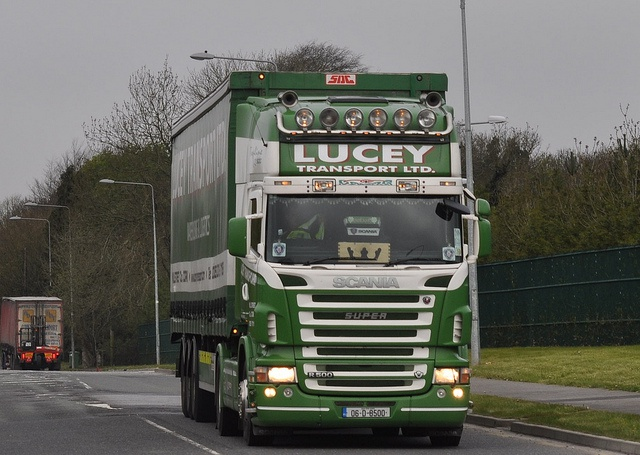Describe the objects in this image and their specific colors. I can see truck in darkgray, black, gray, and darkgreen tones and truck in darkgray, black, gray, and maroon tones in this image. 